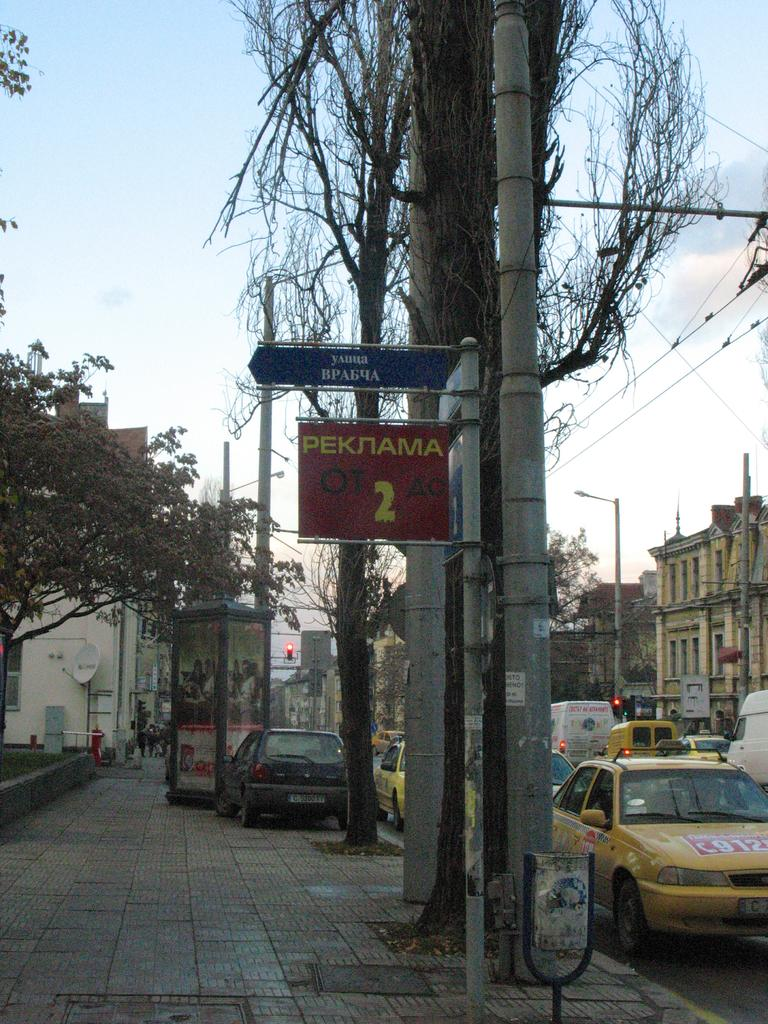Provide a one-sentence caption for the provided image. Street sign next to a taxi cab that says Peknama 2. 